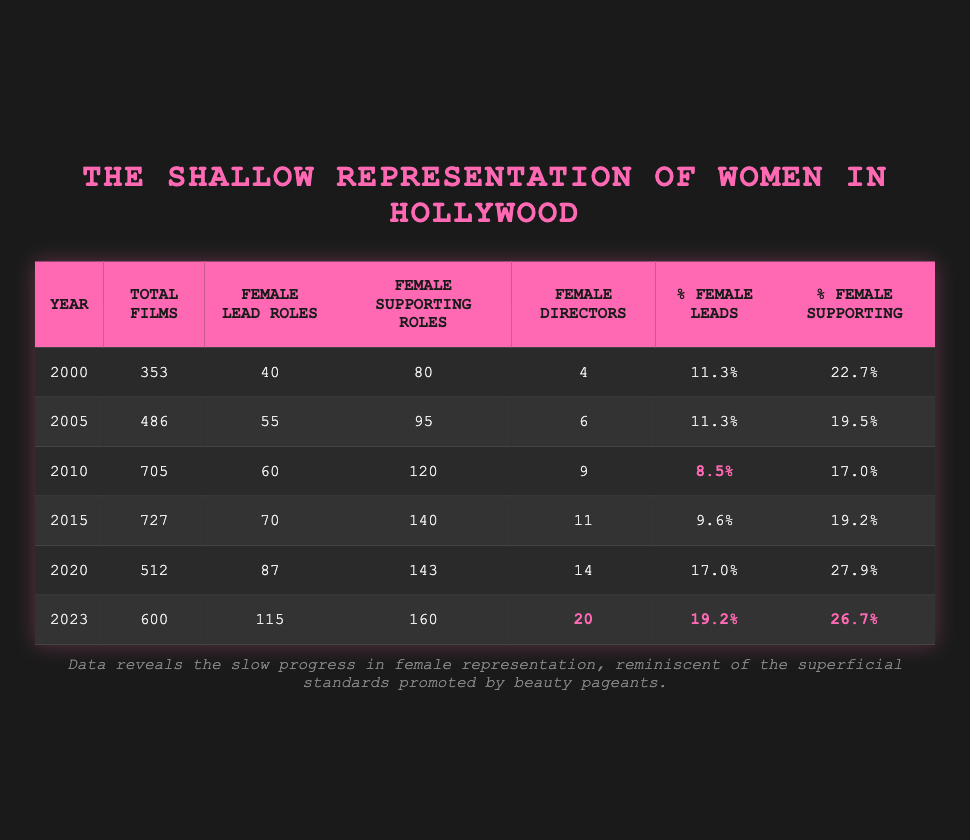What was the total number of films in 2015? The table shows the total number of films for each year. For the year 2015, the total films are listed as 727.
Answer: 727 In which year did female directors first exceed 10? Looking at the table for the number of female directors, they first exceed 10 in the year 2023, where the number is 20.
Answer: 2023 What is the percentage of female supporting roles in 2010? The table indicates that for the year 2010, the percentage of female supporting roles is listed as 17.0%.
Answer: 17.0% How many female lead roles were there from 2010 to 2023 combined? To find the total number of female lead roles from 2010 to 2023, we need to sum these values: 60 (2010) + 70 (2015) + 87 (2020) + 115 (2023) = 332.
Answer: 332 Is the percentage of female lead roles higher in 2020 than in 2015? By comparing the two years, percentage of female leads in 2020 is 17.0% whereas in 2015 it is 9.6%. This means it is higher in 2020.
Answer: Yes What was the change in the percentage of female leads from 2000 to 2023? The percentage of female leads in 2000 is 11.3% and in 2023 it is 19.2%. To find the change, we subtract: 19.2% - 11.3% = 7.9%.
Answer: 7.9% What year saw the highest number of female supporting roles? By checking the female supporting roles for each year, the highest is in 2023 with 160 roles.
Answer: 2023 How much did the total number of films change from 2000 to 2023? The total number of films in 2000 is 353 and in 2023 it is 600. The change is calculated by subtracting: 600 - 353 = 247.
Answer: 247 Which year had the lowest percentage of female leads? The table shows that the year 2010 had the lowest percentage of female leads at 8.5%.
Answer: 2010 